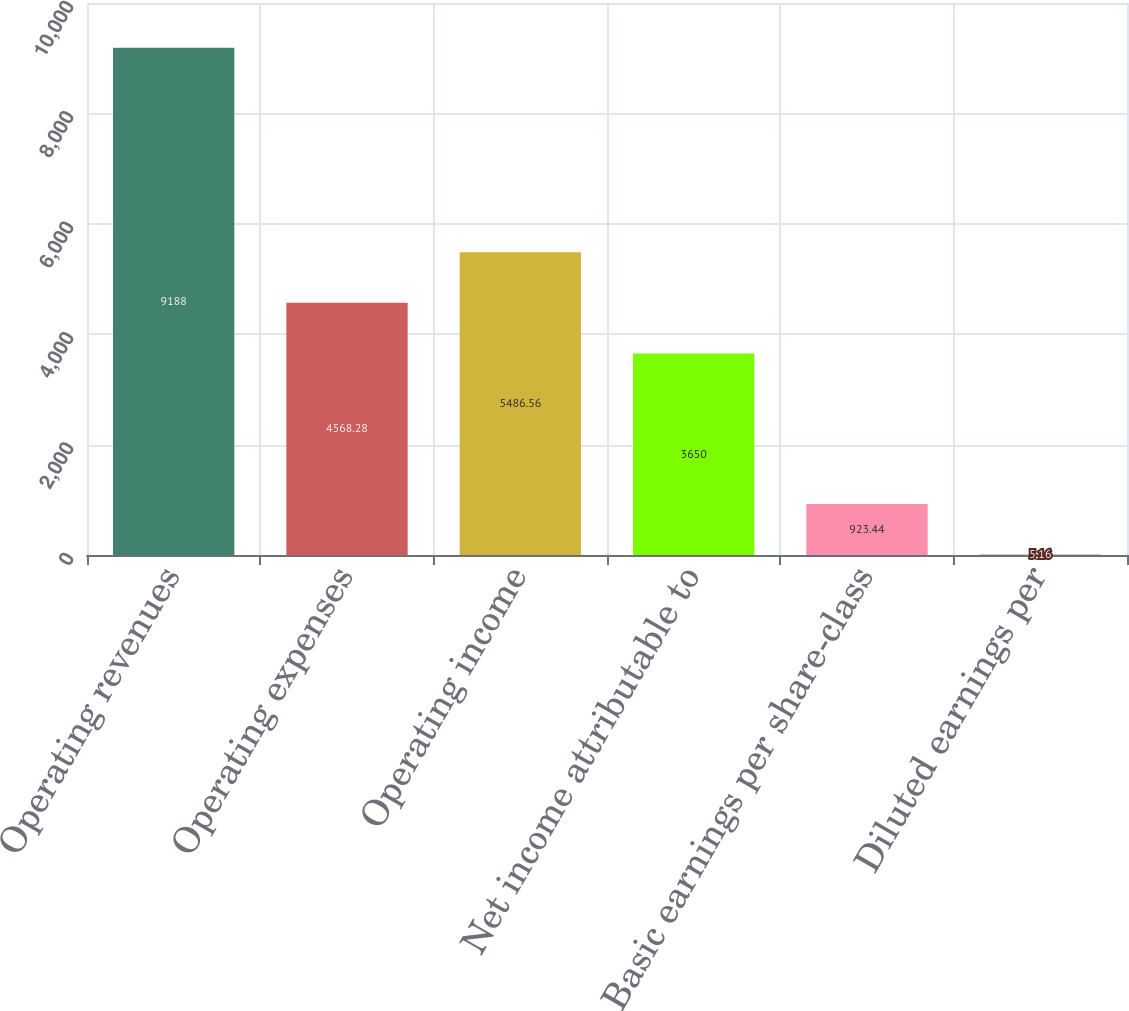Convert chart to OTSL. <chart><loc_0><loc_0><loc_500><loc_500><bar_chart><fcel>Operating revenues<fcel>Operating expenses<fcel>Operating income<fcel>Net income attributable to<fcel>Basic earnings per share-class<fcel>Diluted earnings per<nl><fcel>9188<fcel>4568.28<fcel>5486.56<fcel>3650<fcel>923.44<fcel>5.16<nl></chart> 